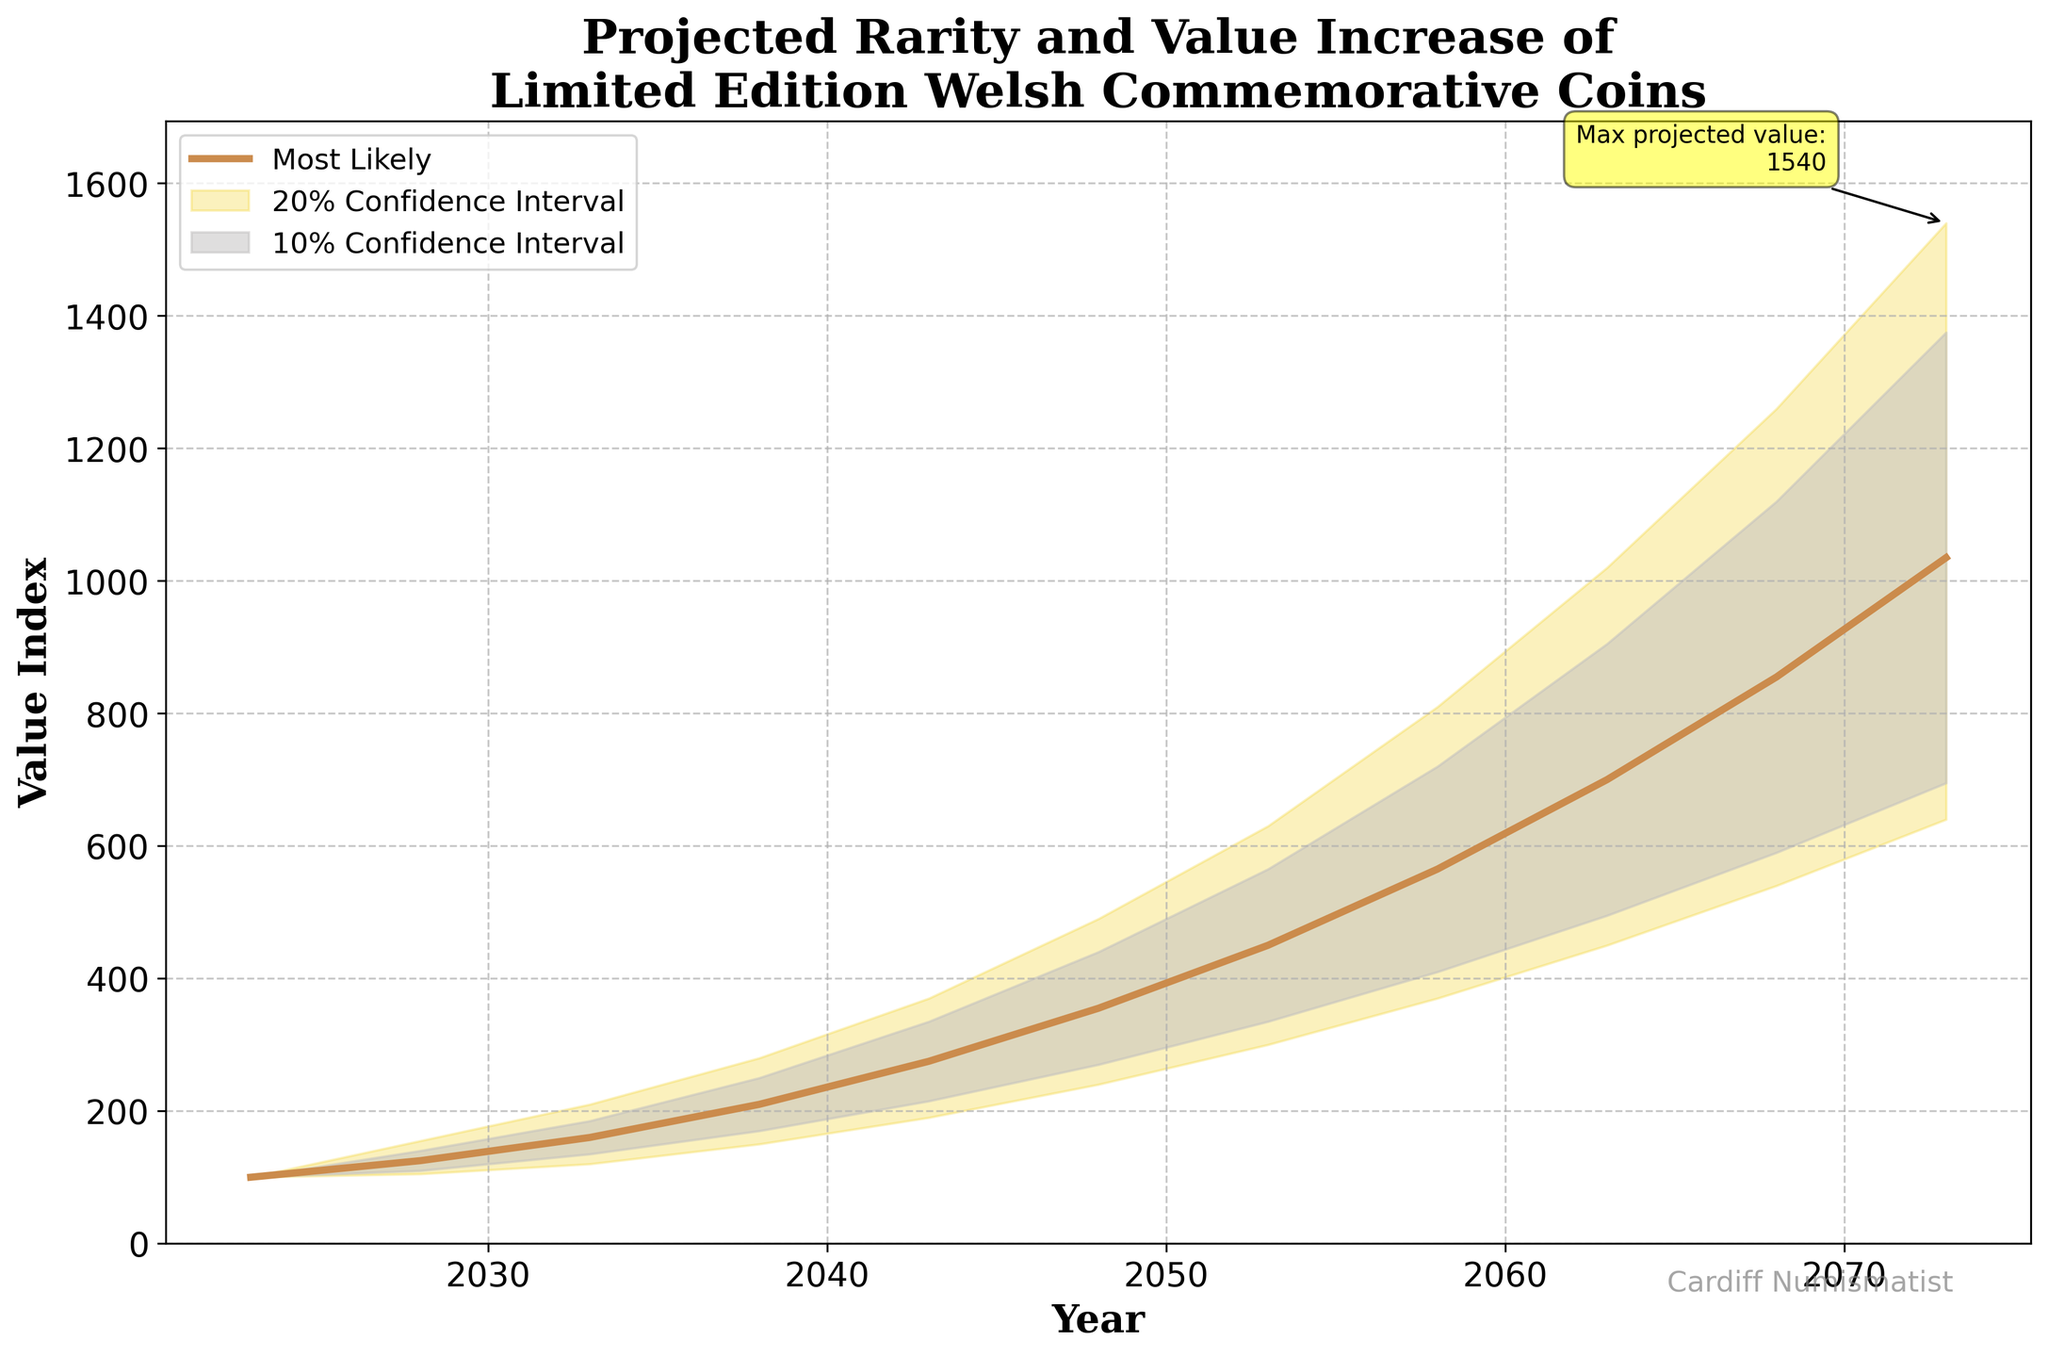what is the title of the plot? The title of the plot can be found at the top of the figure. It reads "Projected Rarity and Value Increase of Limited Edition Welsh Commemorative Coins" with additional line breaks for clarity.
Answer: Projected Rarity and Value Increase of Limited Edition Welsh Commemorative Coins What color represents the 20% confidence interval? The 20% confidence interval is represented by the lighter shaded area. In the custom colormap, this is likely the lightest bronze color (closest to gold).
Answer: Light gold/bronze What are the projected values for the year 2038? To find the projected values for 2038, refer to the data points on the fan chart at the year 2038. The most likely value is 210, the lower 10% confidence interval is 170, the upper 10% confidence interval is 250, the lower 20% confidence interval is 150, and the upper 20% confidence interval is 280.
Answer: Most likely: 210, Low10: 170, High10: 250, Low20: 150, High20: 280 Which year shows the highest most likely projected value, and what is that value? The highest most likely projected value can be identified by following the 'Most Likely' curve to the highest point. This occurs in the year 2073, with a value of 1035.
Answer: Year: 2073, Value: 1035 By how much does the upper 20% confidence interval increase from 2028 to 2048? Subtract the upper 20% confidence interval value in 2028 (155) from the value in 2048 (490). The difference is 490 - 155 = 335.
Answer: 335 Compare the values within the 10% confidence interval for the years 2033 and 2053. Which year has a higher value range and by how much? The range for 2033 within the 10% confidence interval can be calculated by subtracting the low 10% value from the high 10% value (185 - 135 = 50). For 2053, the range is (565 - 335 = 230). The difference between these ranges is 230 - 50 = 180.
Answer: 2053 by 180 What is the confidence interval range in 2068? The confidence interval range in 2068 within the 20% interval can be calculated by subtracting the low 20% value from the high 20% value (1260 - 540).
Answer: 720 What are the projected values for the starting year, 2023, across all intervals? For 2023, the projected values are the same across all intervals: most likely value is 100, both low and high 10% confidence intervals are 100, and both low and high 20% confidence intervals are 100.
Answer: 100 for all intervals What trend do you observe in the most likely projected values from 2023 to 2073? The most likely projected values display an upward trend, starting at 100 in 2023 and increasing steadily to 1035 in 2073.
Answer: Upward trend 